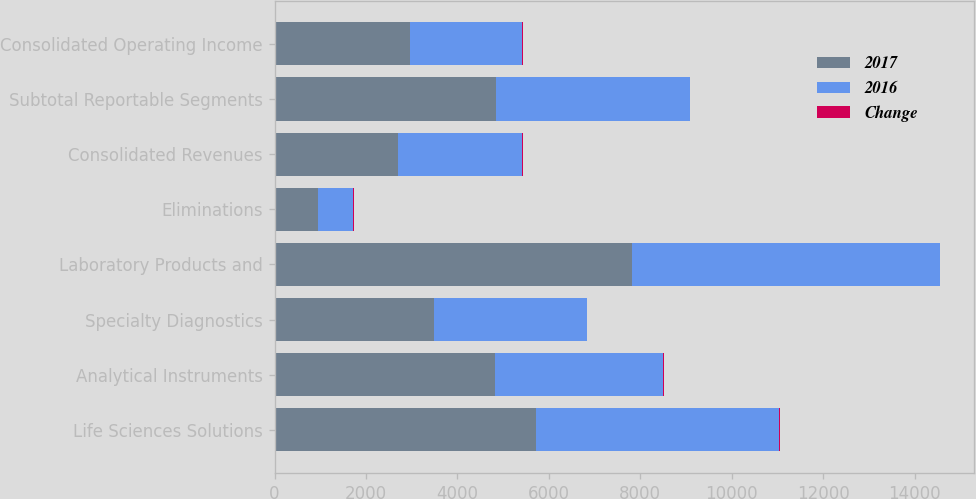<chart> <loc_0><loc_0><loc_500><loc_500><stacked_bar_chart><ecel><fcel>Life Sciences Solutions<fcel>Analytical Instruments<fcel>Specialty Diagnostics<fcel>Laboratory Products and<fcel>Eliminations<fcel>Consolidated Revenues<fcel>Subtotal Reportable Segments<fcel>Consolidated Operating Income<nl><fcel>2017<fcel>5728<fcel>4821<fcel>3486<fcel>7825<fcel>942<fcel>2709<fcel>4852<fcel>2960<nl><fcel>2016<fcel>5317<fcel>3668<fcel>3339<fcel>6724<fcel>774<fcel>2709<fcel>4231<fcel>2458<nl><fcel>Change<fcel>8<fcel>31<fcel>4<fcel>16<fcel>22<fcel>14<fcel>15<fcel>20<nl></chart> 